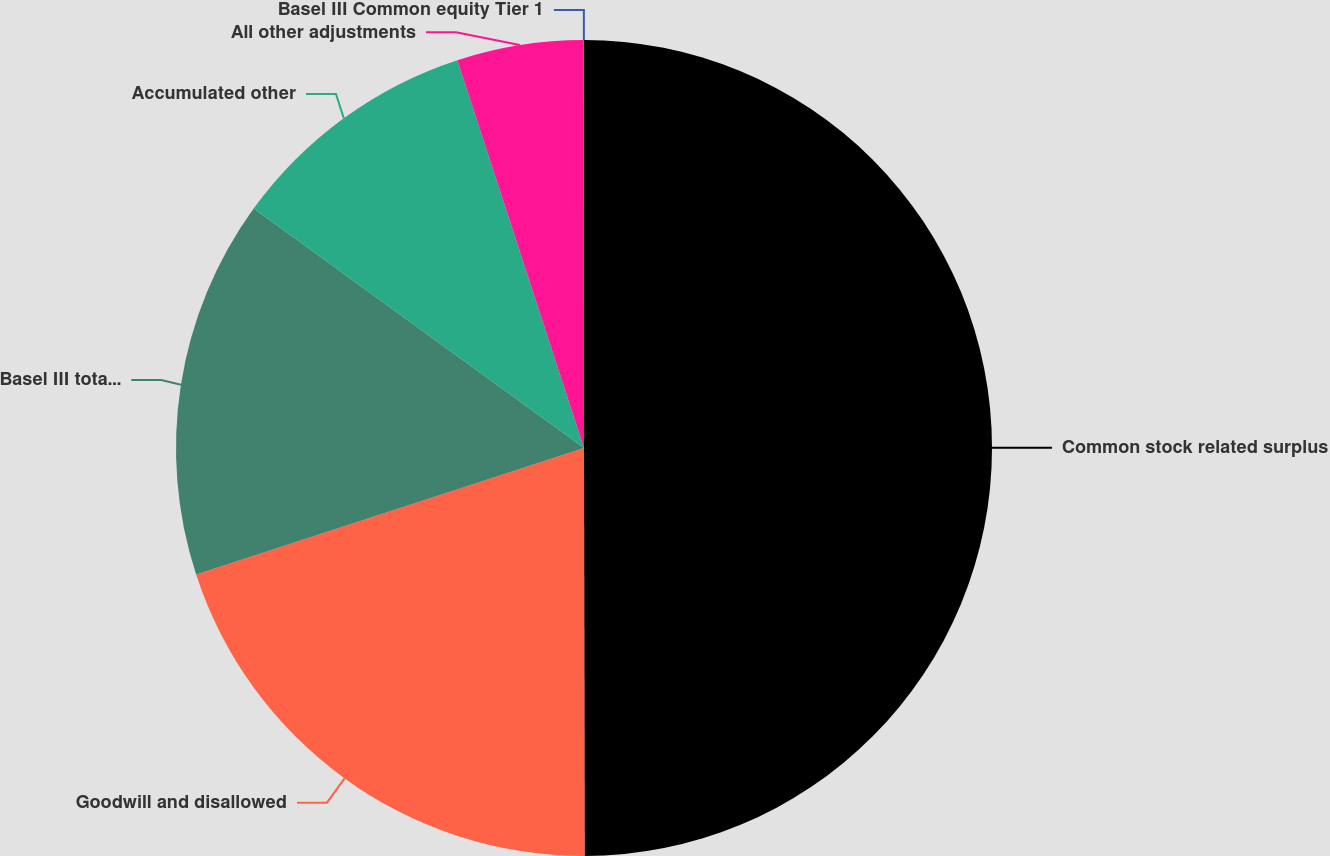<chart> <loc_0><loc_0><loc_500><loc_500><pie_chart><fcel>Common stock related surplus<fcel>Goodwill and disallowed<fcel>Basel III total threshold<fcel>Accumulated other<fcel>All other adjustments<fcel>Basel III Common equity Tier 1<nl><fcel>49.98%<fcel>20.0%<fcel>15.0%<fcel>10.0%<fcel>5.01%<fcel>0.01%<nl></chart> 